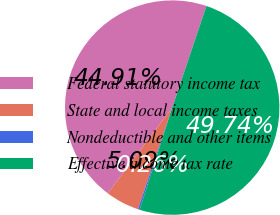Convert chart. <chart><loc_0><loc_0><loc_500><loc_500><pie_chart><fcel>Federal statutory income tax<fcel>State and local income taxes<fcel>Nondeductible and other items<fcel>Effective income tax rate<nl><fcel>44.91%<fcel>5.09%<fcel>0.26%<fcel>49.74%<nl></chart> 